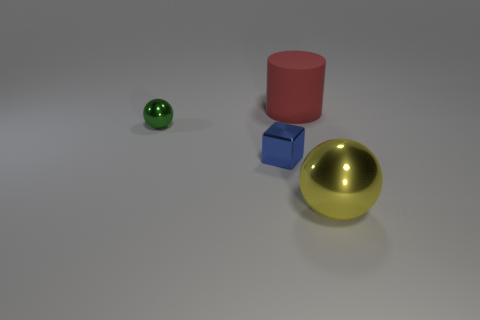Add 1 tiny blue metallic blocks. How many objects exist? 5 Subtract all cubes. How many objects are left? 3 Subtract all small yellow things. Subtract all yellow metallic balls. How many objects are left? 3 Add 1 tiny green metal things. How many tiny green metal things are left? 2 Add 2 tiny gray objects. How many tiny gray objects exist? 2 Subtract 0 red spheres. How many objects are left? 4 